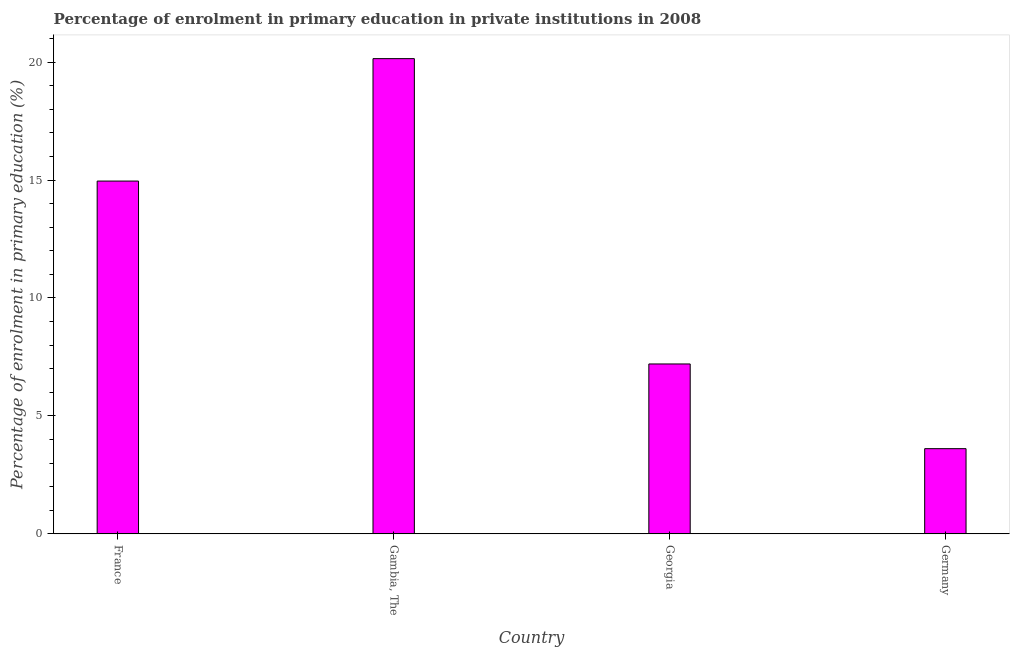Does the graph contain grids?
Your answer should be very brief. No. What is the title of the graph?
Provide a short and direct response. Percentage of enrolment in primary education in private institutions in 2008. What is the label or title of the X-axis?
Your answer should be very brief. Country. What is the label or title of the Y-axis?
Your answer should be very brief. Percentage of enrolment in primary education (%). What is the enrolment percentage in primary education in Georgia?
Offer a very short reply. 7.2. Across all countries, what is the maximum enrolment percentage in primary education?
Make the answer very short. 20.15. Across all countries, what is the minimum enrolment percentage in primary education?
Give a very brief answer. 3.61. In which country was the enrolment percentage in primary education maximum?
Make the answer very short. Gambia, The. What is the sum of the enrolment percentage in primary education?
Provide a succinct answer. 45.92. What is the difference between the enrolment percentage in primary education in Gambia, The and Germany?
Keep it short and to the point. 16.53. What is the average enrolment percentage in primary education per country?
Offer a terse response. 11.48. What is the median enrolment percentage in primary education?
Keep it short and to the point. 11.08. In how many countries, is the enrolment percentage in primary education greater than 6 %?
Offer a very short reply. 3. What is the ratio of the enrolment percentage in primary education in France to that in Germany?
Make the answer very short. 4.14. Is the enrolment percentage in primary education in France less than that in Georgia?
Provide a short and direct response. No. Is the difference between the enrolment percentage in primary education in Georgia and Germany greater than the difference between any two countries?
Make the answer very short. No. What is the difference between the highest and the second highest enrolment percentage in primary education?
Ensure brevity in your answer.  5.19. What is the difference between the highest and the lowest enrolment percentage in primary education?
Make the answer very short. 16.53. Are all the bars in the graph horizontal?
Keep it short and to the point. No. What is the Percentage of enrolment in primary education (%) in France?
Make the answer very short. 14.96. What is the Percentage of enrolment in primary education (%) of Gambia, The?
Your answer should be compact. 20.15. What is the Percentage of enrolment in primary education (%) of Georgia?
Your answer should be very brief. 7.2. What is the Percentage of enrolment in primary education (%) in Germany?
Offer a very short reply. 3.61. What is the difference between the Percentage of enrolment in primary education (%) in France and Gambia, The?
Your answer should be compact. -5.19. What is the difference between the Percentage of enrolment in primary education (%) in France and Georgia?
Ensure brevity in your answer.  7.75. What is the difference between the Percentage of enrolment in primary education (%) in France and Germany?
Offer a very short reply. 11.34. What is the difference between the Percentage of enrolment in primary education (%) in Gambia, The and Georgia?
Make the answer very short. 12.94. What is the difference between the Percentage of enrolment in primary education (%) in Gambia, The and Germany?
Your response must be concise. 16.53. What is the difference between the Percentage of enrolment in primary education (%) in Georgia and Germany?
Provide a short and direct response. 3.59. What is the ratio of the Percentage of enrolment in primary education (%) in France to that in Gambia, The?
Offer a terse response. 0.74. What is the ratio of the Percentage of enrolment in primary education (%) in France to that in Georgia?
Offer a terse response. 2.08. What is the ratio of the Percentage of enrolment in primary education (%) in France to that in Germany?
Your response must be concise. 4.14. What is the ratio of the Percentage of enrolment in primary education (%) in Gambia, The to that in Georgia?
Provide a succinct answer. 2.8. What is the ratio of the Percentage of enrolment in primary education (%) in Gambia, The to that in Germany?
Provide a succinct answer. 5.58. What is the ratio of the Percentage of enrolment in primary education (%) in Georgia to that in Germany?
Offer a very short reply. 1.99. 